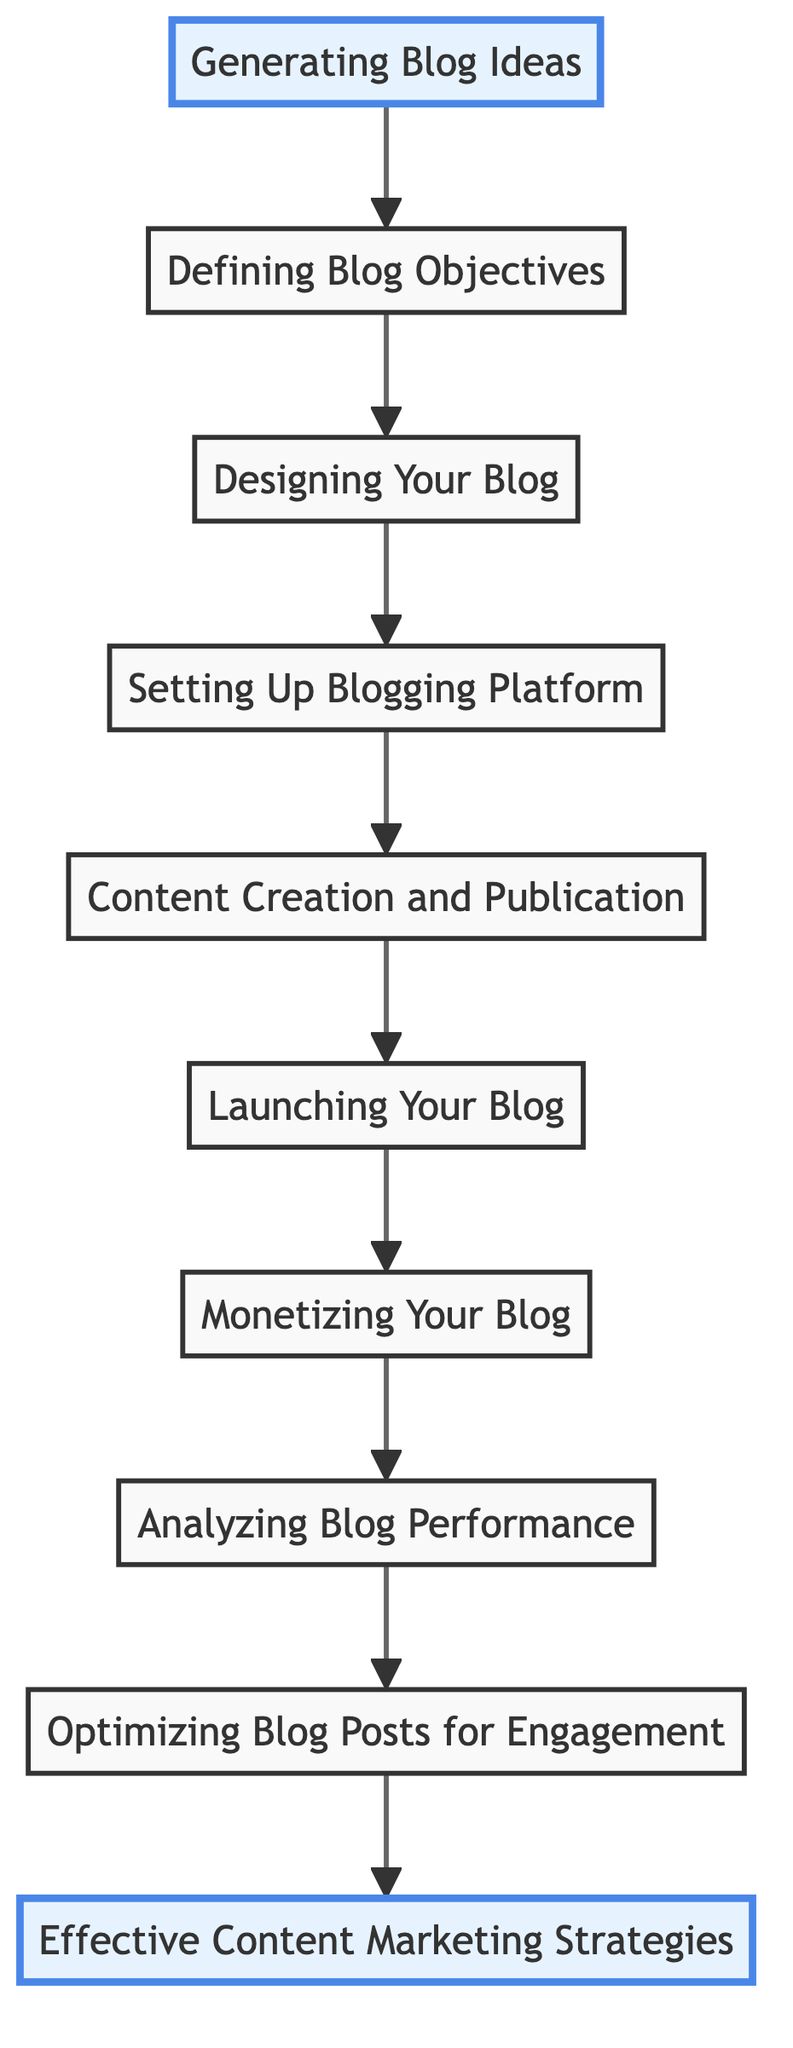What is the first step in the flowchart? The first step in the flowchart is "Generating Blog Ideas," which is the starting point of the blogging process.
Answer: Generating Blog Ideas How many total steps are represented in the flowchart? The flowchart contains a total of 10 steps, each representing a different part of the blogging process from idea generation to marketing strategies.
Answer: 10 Which step directly follows "Content Creation and Publication"? "Launching Your Blog" directly follows "Content Creation and Publication," indicating the timeline of blogging.
Answer: Launching Your Blog What is the last step in the diagram? The last step in the diagram is "Effective Content Marketing Strategies," representing the final phase of monetizing and promoting the blog.
Answer: Effective Content Marketing Strategies Which steps are highlighted in the flowchart? The highlighted steps are "Generating Blog Ideas" and "Optimizing Blog Posts for Engagement," emphasizing their importance in the process.
Answer: Generating Blog Ideas and Optimizing Blog Posts for Engagement What is the relationship between "Monetizing Your Blog" and "Analyzing Blog Performance"? "Monetizing Your Blog" precedes "Analyzing Blog Performance," indicating that understanding how to make money from the blog comes before assessing its performance.
Answer: Precedes What step comes before "Launching Your Blog"? The step that comes before "Launching Your Blog" is "Content Creation and Publication," showing that content needs to be created before the blog can be launched.
Answer: Content Creation and Publication Which two nodes connect directly to "Optimizing Blog Posts for Engagement"? "Analyzing Blog Performance" connects directly to "Optimizing Blog Posts for Engagement," and "Effective Content Marketing Strategies" follows it to demonstrate sequential actions.
Answer: Analyzing Blog Performance and Effective Content Marketing Strategies What does the flowchart suggest as necessary before setting up a blogging platform? The flowchart suggests that "Designing Your Blog" is necessary before "Setting Up Blogging Platform," indicating a sequential requirement.
Answer: Designing Your Blog 